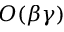Convert formula to latex. <formula><loc_0><loc_0><loc_500><loc_500>O ( \beta \gamma )</formula> 